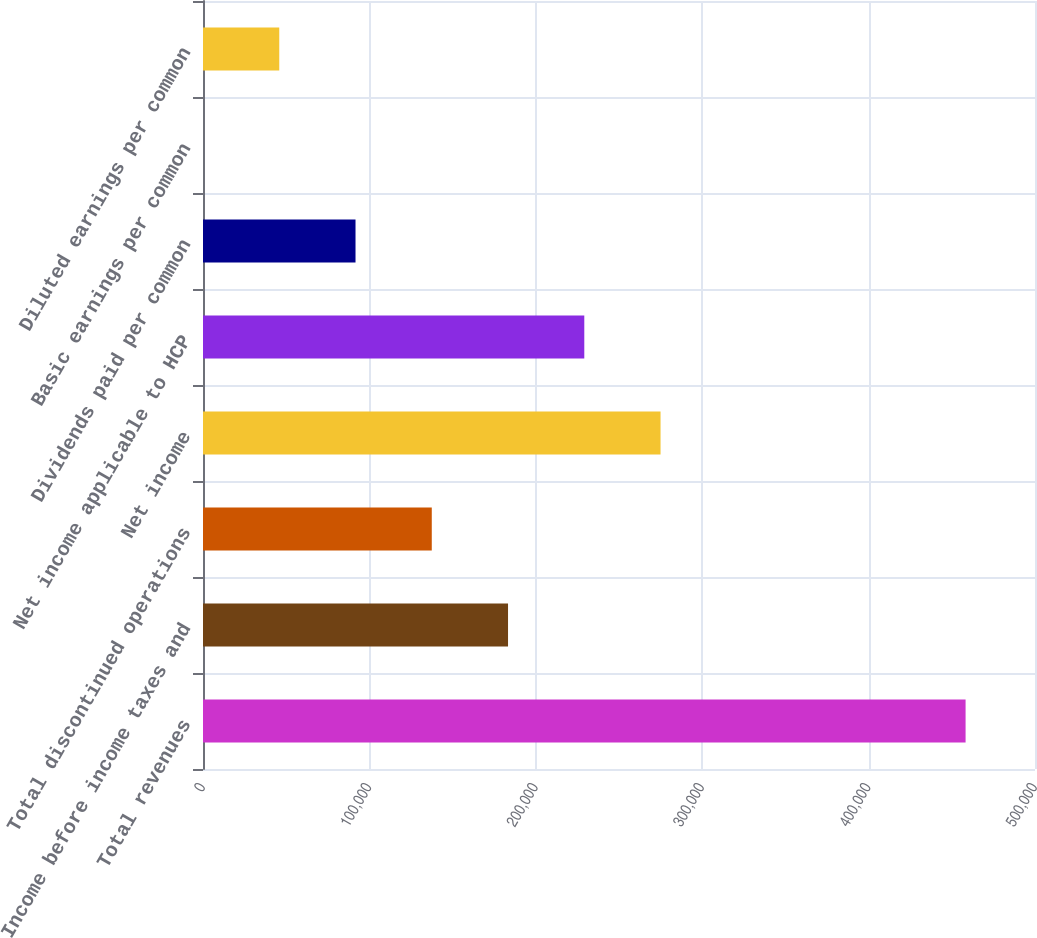<chart> <loc_0><loc_0><loc_500><loc_500><bar_chart><fcel>Total revenues<fcel>Income before income taxes and<fcel>Total discontinued operations<fcel>Net income<fcel>Net income applicable to HCP<fcel>Dividends paid per common<fcel>Basic earnings per common<fcel>Diluted earnings per common<nl><fcel>458281<fcel>183312<fcel>137484<fcel>274969<fcel>229141<fcel>91656.3<fcel>0.15<fcel>45828.2<nl></chart> 